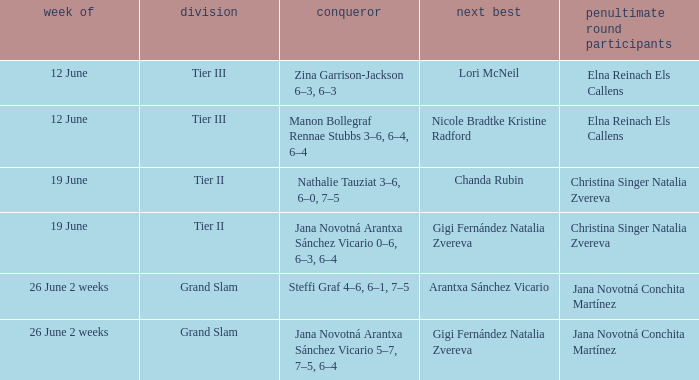Who is the winner in the week listed as 26 June 2 weeks, when the runner-up is Arantxa Sánchez Vicario? Steffi Graf 4–6, 6–1, 7–5. 